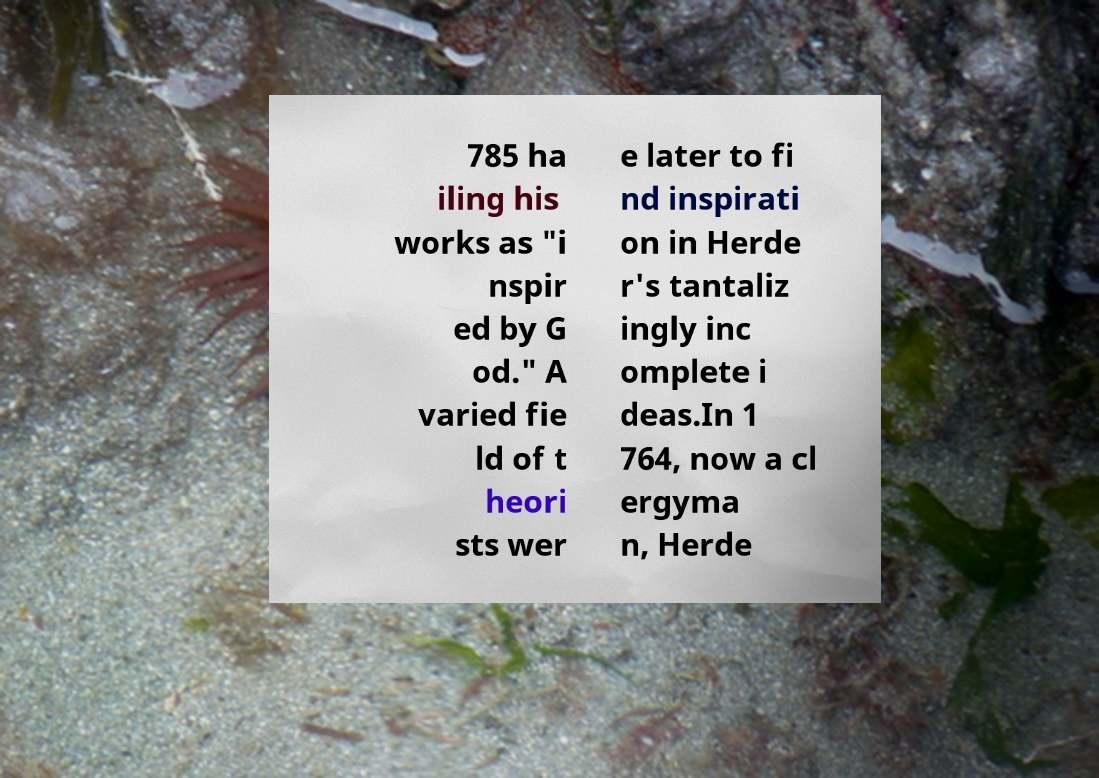Please identify and transcribe the text found in this image. 785 ha iling his works as "i nspir ed by G od." A varied fie ld of t heori sts wer e later to fi nd inspirati on in Herde r's tantaliz ingly inc omplete i deas.In 1 764, now a cl ergyma n, Herde 